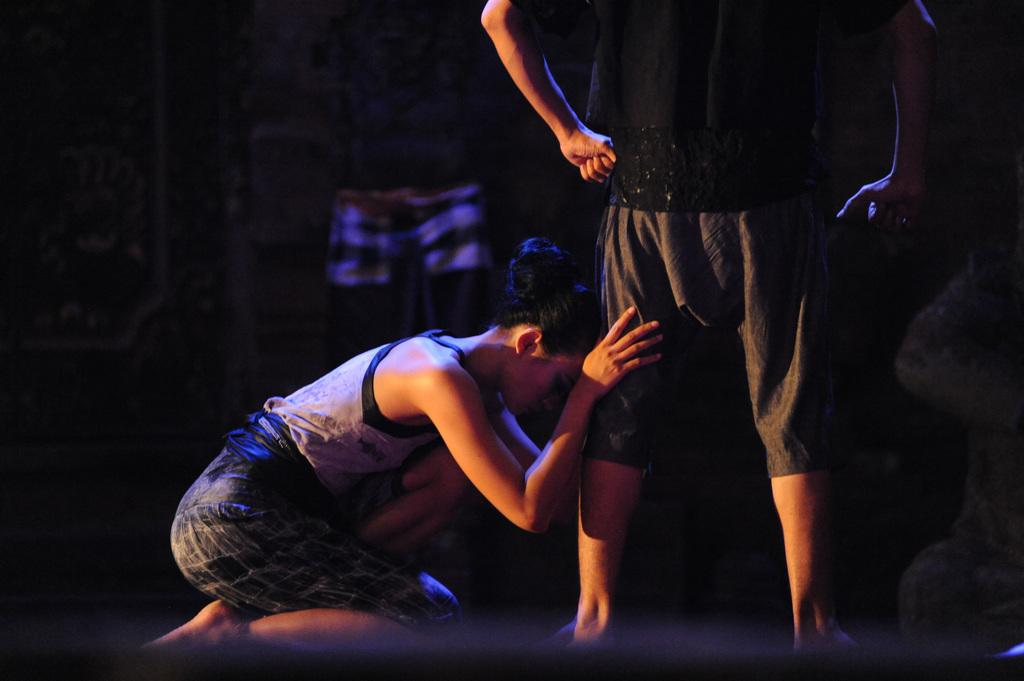What is the position of the man in the image? The man is standing in the image. What is the position of the girl in the image? The girl is sitting in the image. How is the girl interacting with the man? The girl is holding the man's legs in the image. What type of rabbit can be seen on the scale in the image? There is no rabbit or scale present in the image. What is the cause of the war depicted in the image? There is no war depicted in the image. 